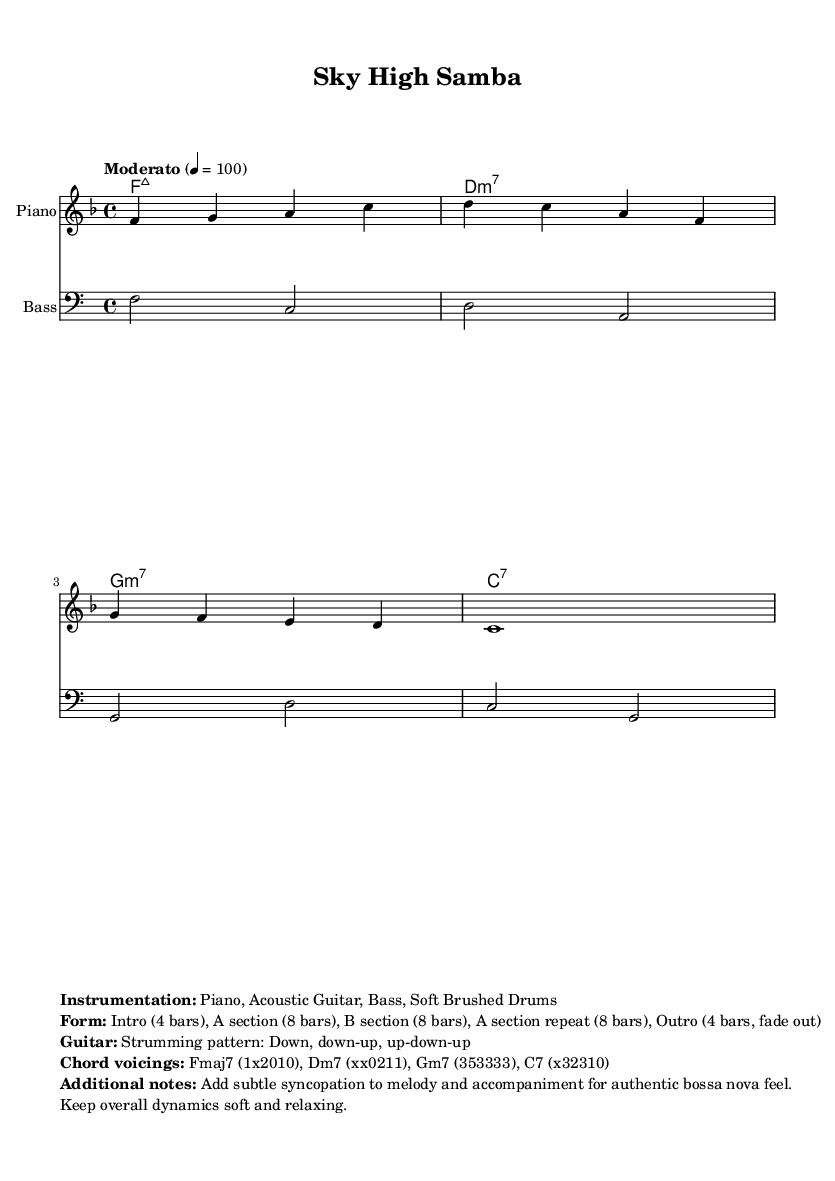What is the key signature of this music? The key signature is F major, which includes one flat (B flat). You can determine the key signature by looking at the first section of the music, where it specifies the key before the time signature.
Answer: F major What is the time signature of this piece? The time signature is 4/4, which indicates that there are four beats in each measure and the quarter note gets one beat. This can be found next to the key signature at the beginning of the score.
Answer: 4/4 What is the tempo marking for the piece? The tempo marking indicates a "Moderato" pace, specified at a speed of 100 beats per minute. This is typically located above the staff at the beginning of the piece.
Answer: Moderato 4 = 100 How many bars are in the Intro section? The Intro section contains 4 bars, as noted in the form description provided in the markup section of the score. This specifies the structure of the music.
Answer: 4 bars What instrument plays the melody in this score? The melody is played by the "Piano," which is indicated right above the staff that contains the melody notes. This specification tells us which instrument is performing the primary voice.
Answer: Piano What is the strumming pattern for the guitar part? The guitar strumming pattern is "Down, down-up, up-down-up," which is noted in the markup section of the score. It describes how the guitarist should strum the chords.
Answer: Down, down-up, up-down-up What type of feel is suggested for the overall dynamics? The overall dynamics should be soft and relaxing, as indicated in the additional notes section. This instruction helps create the intended atmosphere for the music.
Answer: Soft and relaxing 